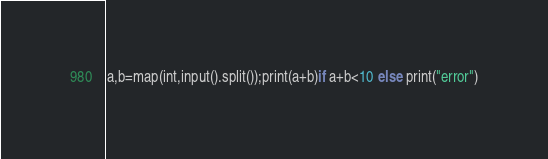Convert code to text. <code><loc_0><loc_0><loc_500><loc_500><_Python_>a,b=map(int,input().split());print(a+b)if a+b<10 else print("error")</code> 